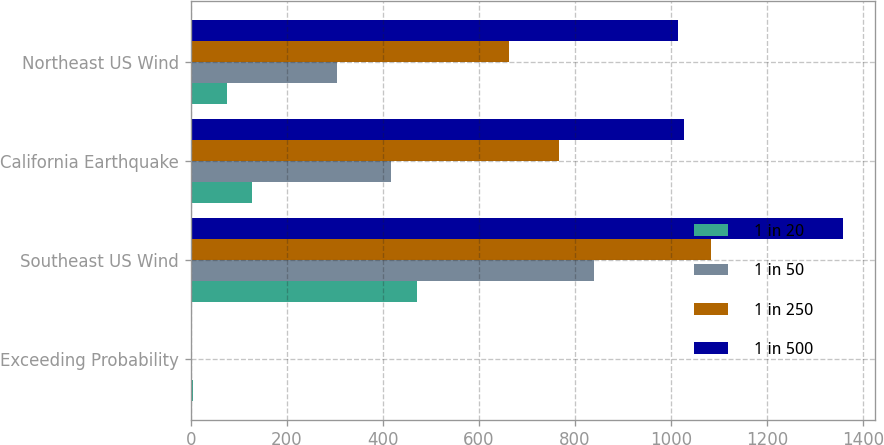Convert chart to OTSL. <chart><loc_0><loc_0><loc_500><loc_500><stacked_bar_chart><ecel><fcel>Exceeding Probability<fcel>Southeast US Wind<fcel>California Earthquake<fcel>Northeast US Wind<nl><fcel>1 in 20<fcel>5<fcel>472<fcel>127<fcel>76<nl><fcel>1 in 50<fcel>2<fcel>840<fcel>416<fcel>305<nl><fcel>1 in 250<fcel>1<fcel>1084<fcel>767<fcel>663<nl><fcel>1 in 500<fcel>0.4<fcel>1358<fcel>1028<fcel>1014<nl></chart> 